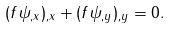<formula> <loc_0><loc_0><loc_500><loc_500>( f \psi _ { , x } ) _ { , x } + ( f \psi _ { , y } ) _ { , y } = 0 .</formula> 